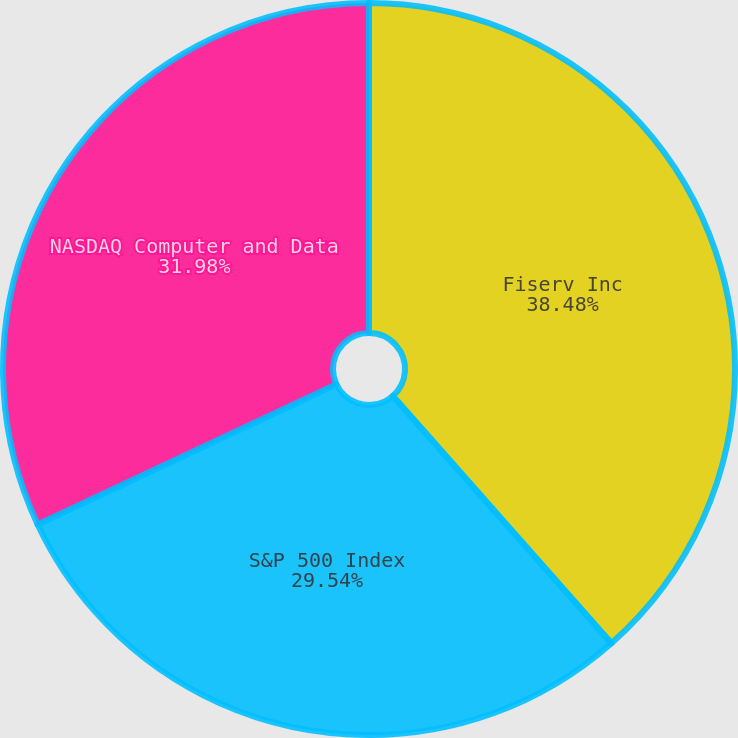Convert chart. <chart><loc_0><loc_0><loc_500><loc_500><pie_chart><fcel>Fiserv Inc<fcel>S&P 500 Index<fcel>NASDAQ Computer and Data<nl><fcel>38.48%<fcel>29.54%<fcel>31.98%<nl></chart> 